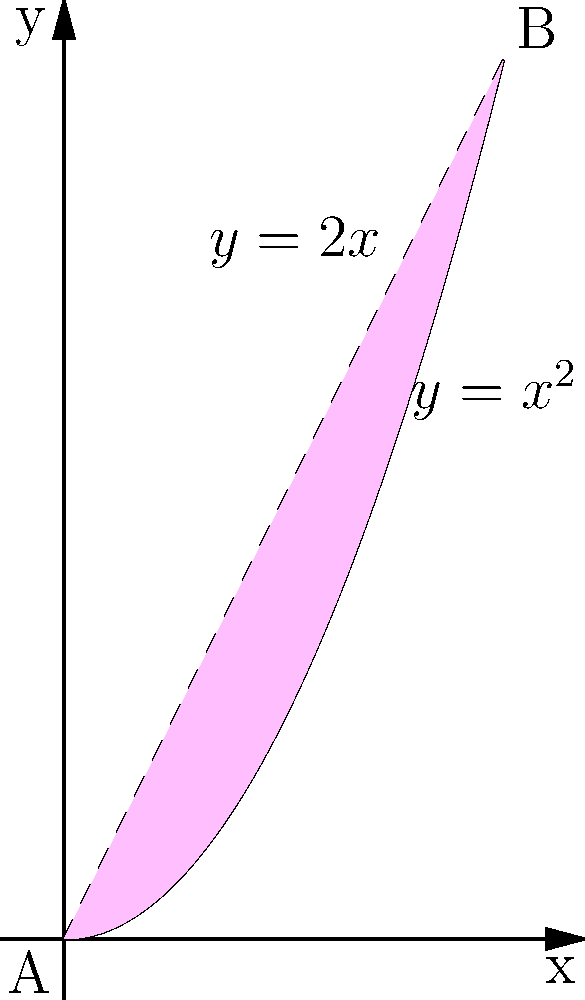Imagine you're planning a heart-shaped garden for your daughter's quinceañera. The garden's shape is formed by the intersection of two flower beds: one following the curve $y = x^2$ and the other following $y = 2x$. What is the area of this heart-shaped garden in square meters? Let's approach this step-by-step, mi amor:

1) First, we need to find where the curves intersect. We can do this by setting the equations equal to each other:
   $x^2 = 2x$
   $x^2 - 2x = 0$
   $x(x - 2) = 0$
   So, $x = 0$ or $x = 2$

2) The points of intersection are $(0,0)$ and $(2,4)$.

3) To find the area, we need to integrate the difference between the two functions from $x = 0$ to $x = 2$:

   Area $= \int_0^2 (2x - x^2) dx$

4) Let's solve this integral:
   $\int_0^2 (2x - x^2) dx = [x^2 - \frac{x^3}{3}]_0^2$

5) Now, let's evaluate:
   $= (2^2 - \frac{2^3}{3}) - (0^2 - \frac{0^3}{3})$
   $= (4 - \frac{8}{3}) - 0$
   $= \frac{12}{3} - \frac{8}{3}$
   $= \frac{4}{3}$

6) Therefore, the area of our heart-shaped garden is $\frac{4}{3}$ square meters.

Isn't that lovely? Just like in your favorite romantic comedies, love can be measured in unexpected ways!
Answer: $\frac{4}{3}$ square meters 